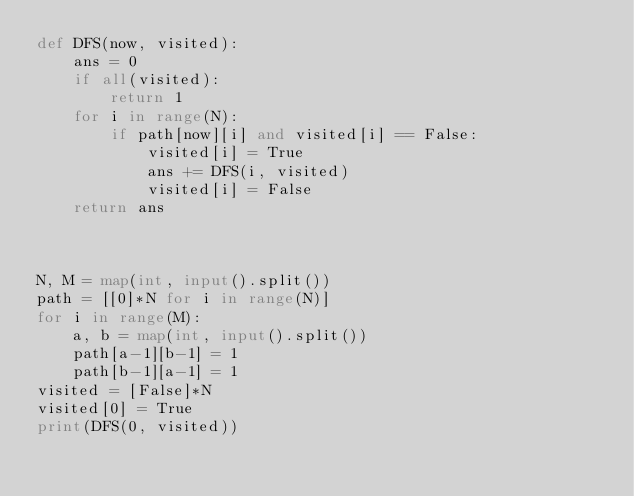Convert code to text. <code><loc_0><loc_0><loc_500><loc_500><_Python_>def DFS(now, visited):
    ans = 0
    if all(visited):
        return 1
    for i in range(N):
        if path[now][i] and visited[i] == False:
            visited[i] = True
            ans += DFS(i, visited)
            visited[i] = False
    return ans
    


N, M = map(int, input().split())
path = [[0]*N for i in range(N)]
for i in range(M):
    a, b = map(int, input().split())
    path[a-1][b-1] = 1
    path[b-1][a-1] = 1
visited = [False]*N
visited[0] = True
print(DFS(0, visited))


</code> 